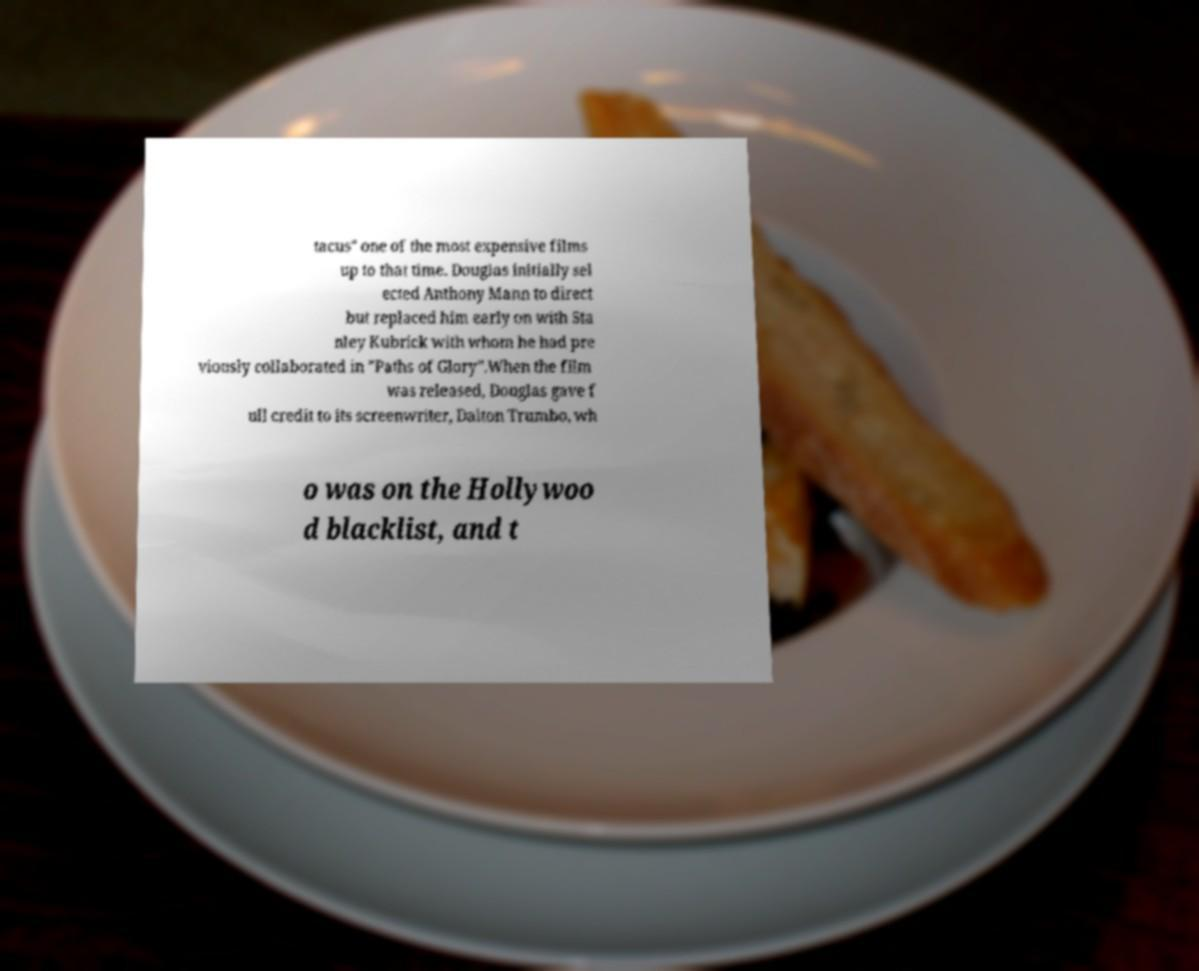For documentation purposes, I need the text within this image transcribed. Could you provide that? tacus" one of the most expensive films up to that time. Douglas initially sel ected Anthony Mann to direct but replaced him early on with Sta nley Kubrick with whom he had pre viously collaborated in "Paths of Glory".When the film was released, Douglas gave f ull credit to its screenwriter, Dalton Trumbo, wh o was on the Hollywoo d blacklist, and t 